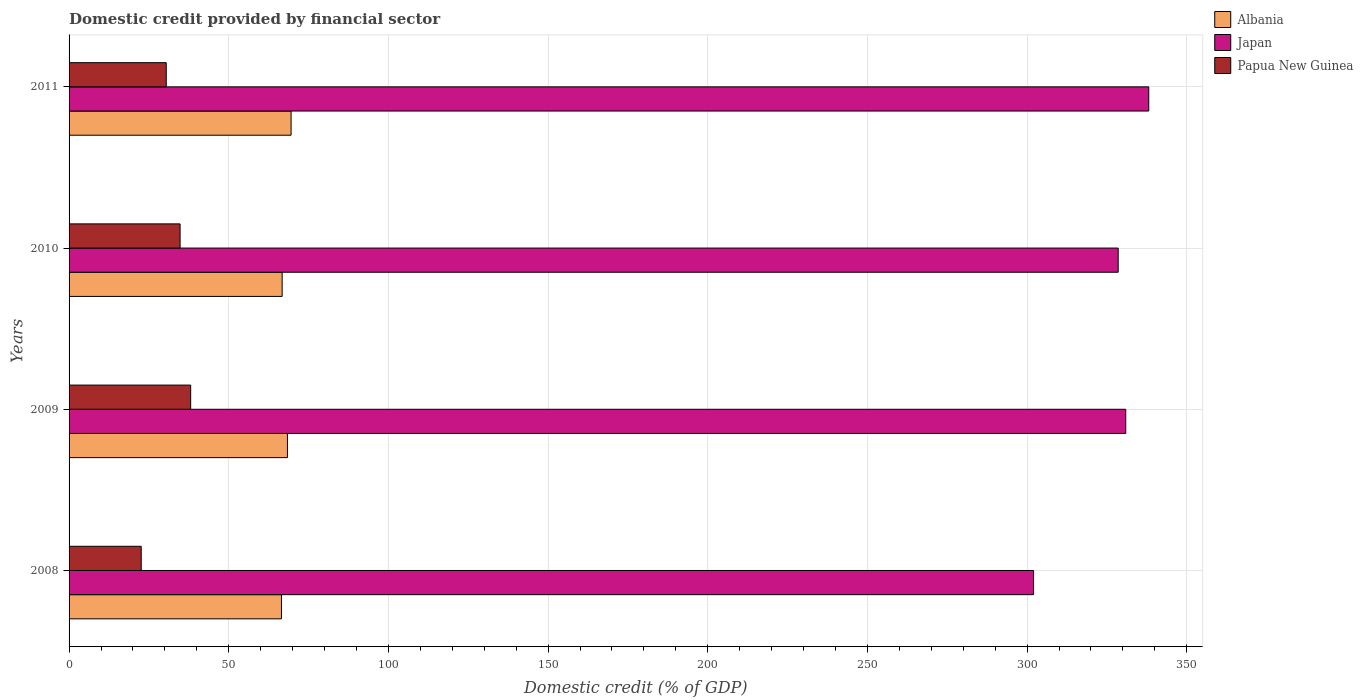How many different coloured bars are there?
Offer a very short reply. 3. Are the number of bars on each tick of the Y-axis equal?
Give a very brief answer. Yes. How many bars are there on the 4th tick from the bottom?
Your response must be concise. 3. What is the label of the 4th group of bars from the top?
Provide a short and direct response. 2008. In how many cases, is the number of bars for a given year not equal to the number of legend labels?
Your answer should be very brief. 0. What is the domestic credit in Albania in 2011?
Give a very brief answer. 69.52. Across all years, what is the maximum domestic credit in Papua New Guinea?
Offer a very short reply. 38.08. Across all years, what is the minimum domestic credit in Albania?
Offer a terse response. 66.51. What is the total domestic credit in Papua New Guinea in the graph?
Ensure brevity in your answer.  125.86. What is the difference between the domestic credit in Papua New Guinea in 2010 and that in 2011?
Your answer should be very brief. 4.34. What is the difference between the domestic credit in Albania in 2010 and the domestic credit in Japan in 2008?
Offer a terse response. -235.29. What is the average domestic credit in Papua New Guinea per year?
Offer a terse response. 31.46. In the year 2008, what is the difference between the domestic credit in Papua New Guinea and domestic credit in Japan?
Provide a short and direct response. -279.43. What is the ratio of the domestic credit in Japan in 2009 to that in 2011?
Make the answer very short. 0.98. Is the domestic credit in Japan in 2009 less than that in 2011?
Make the answer very short. Yes. What is the difference between the highest and the second highest domestic credit in Japan?
Ensure brevity in your answer.  7.2. What is the difference between the highest and the lowest domestic credit in Papua New Guinea?
Offer a terse response. 15.49. What does the 1st bar from the top in 2009 represents?
Offer a very short reply. Papua New Guinea. What does the 2nd bar from the bottom in 2010 represents?
Keep it short and to the point. Japan. Are all the bars in the graph horizontal?
Keep it short and to the point. Yes. How many years are there in the graph?
Make the answer very short. 4. What is the title of the graph?
Your response must be concise. Domestic credit provided by financial sector. What is the label or title of the X-axis?
Your response must be concise. Domestic credit (% of GDP). What is the label or title of the Y-axis?
Keep it short and to the point. Years. What is the Domestic credit (% of GDP) in Albania in 2008?
Offer a terse response. 66.51. What is the Domestic credit (% of GDP) of Japan in 2008?
Provide a succinct answer. 302.02. What is the Domestic credit (% of GDP) of Papua New Guinea in 2008?
Provide a short and direct response. 22.59. What is the Domestic credit (% of GDP) in Albania in 2009?
Offer a terse response. 68.38. What is the Domestic credit (% of GDP) in Japan in 2009?
Offer a terse response. 330.89. What is the Domestic credit (% of GDP) in Papua New Guinea in 2009?
Keep it short and to the point. 38.08. What is the Domestic credit (% of GDP) of Albania in 2010?
Offer a very short reply. 66.72. What is the Domestic credit (% of GDP) of Japan in 2010?
Give a very brief answer. 328.52. What is the Domestic credit (% of GDP) in Papua New Guinea in 2010?
Offer a very short reply. 34.76. What is the Domestic credit (% of GDP) of Albania in 2011?
Provide a succinct answer. 69.52. What is the Domestic credit (% of GDP) in Japan in 2011?
Provide a succinct answer. 338.09. What is the Domestic credit (% of GDP) of Papua New Guinea in 2011?
Keep it short and to the point. 30.43. Across all years, what is the maximum Domestic credit (% of GDP) of Albania?
Your answer should be compact. 69.52. Across all years, what is the maximum Domestic credit (% of GDP) of Japan?
Provide a short and direct response. 338.09. Across all years, what is the maximum Domestic credit (% of GDP) in Papua New Guinea?
Keep it short and to the point. 38.08. Across all years, what is the minimum Domestic credit (% of GDP) of Albania?
Your answer should be compact. 66.51. Across all years, what is the minimum Domestic credit (% of GDP) of Japan?
Provide a short and direct response. 302.02. Across all years, what is the minimum Domestic credit (% of GDP) of Papua New Guinea?
Make the answer very short. 22.59. What is the total Domestic credit (% of GDP) of Albania in the graph?
Your response must be concise. 271.14. What is the total Domestic credit (% of GDP) in Japan in the graph?
Your answer should be very brief. 1299.52. What is the total Domestic credit (% of GDP) in Papua New Guinea in the graph?
Provide a short and direct response. 125.86. What is the difference between the Domestic credit (% of GDP) of Albania in 2008 and that in 2009?
Offer a very short reply. -1.87. What is the difference between the Domestic credit (% of GDP) in Japan in 2008 and that in 2009?
Provide a short and direct response. -28.87. What is the difference between the Domestic credit (% of GDP) of Papua New Guinea in 2008 and that in 2009?
Give a very brief answer. -15.49. What is the difference between the Domestic credit (% of GDP) in Albania in 2008 and that in 2010?
Offer a terse response. -0.21. What is the difference between the Domestic credit (% of GDP) of Japan in 2008 and that in 2010?
Give a very brief answer. -26.5. What is the difference between the Domestic credit (% of GDP) in Papua New Guinea in 2008 and that in 2010?
Your answer should be very brief. -12.17. What is the difference between the Domestic credit (% of GDP) of Albania in 2008 and that in 2011?
Give a very brief answer. -3.01. What is the difference between the Domestic credit (% of GDP) of Japan in 2008 and that in 2011?
Provide a succinct answer. -36.07. What is the difference between the Domestic credit (% of GDP) in Papua New Guinea in 2008 and that in 2011?
Make the answer very short. -7.83. What is the difference between the Domestic credit (% of GDP) in Albania in 2009 and that in 2010?
Your answer should be compact. 1.66. What is the difference between the Domestic credit (% of GDP) of Japan in 2009 and that in 2010?
Give a very brief answer. 2.37. What is the difference between the Domestic credit (% of GDP) in Papua New Guinea in 2009 and that in 2010?
Give a very brief answer. 3.31. What is the difference between the Domestic credit (% of GDP) in Albania in 2009 and that in 2011?
Ensure brevity in your answer.  -1.14. What is the difference between the Domestic credit (% of GDP) in Japan in 2009 and that in 2011?
Provide a short and direct response. -7.2. What is the difference between the Domestic credit (% of GDP) in Papua New Guinea in 2009 and that in 2011?
Give a very brief answer. 7.65. What is the difference between the Domestic credit (% of GDP) in Albania in 2010 and that in 2011?
Keep it short and to the point. -2.79. What is the difference between the Domestic credit (% of GDP) of Japan in 2010 and that in 2011?
Your answer should be compact. -9.57. What is the difference between the Domestic credit (% of GDP) of Papua New Guinea in 2010 and that in 2011?
Your answer should be compact. 4.34. What is the difference between the Domestic credit (% of GDP) in Albania in 2008 and the Domestic credit (% of GDP) in Japan in 2009?
Make the answer very short. -264.38. What is the difference between the Domestic credit (% of GDP) of Albania in 2008 and the Domestic credit (% of GDP) of Papua New Guinea in 2009?
Ensure brevity in your answer.  28.43. What is the difference between the Domestic credit (% of GDP) of Japan in 2008 and the Domestic credit (% of GDP) of Papua New Guinea in 2009?
Your answer should be very brief. 263.94. What is the difference between the Domestic credit (% of GDP) of Albania in 2008 and the Domestic credit (% of GDP) of Japan in 2010?
Your answer should be compact. -262.01. What is the difference between the Domestic credit (% of GDP) of Albania in 2008 and the Domestic credit (% of GDP) of Papua New Guinea in 2010?
Make the answer very short. 31.75. What is the difference between the Domestic credit (% of GDP) in Japan in 2008 and the Domestic credit (% of GDP) in Papua New Guinea in 2010?
Provide a succinct answer. 267.26. What is the difference between the Domestic credit (% of GDP) in Albania in 2008 and the Domestic credit (% of GDP) in Japan in 2011?
Provide a succinct answer. -271.58. What is the difference between the Domestic credit (% of GDP) in Albania in 2008 and the Domestic credit (% of GDP) in Papua New Guinea in 2011?
Your answer should be compact. 36.09. What is the difference between the Domestic credit (% of GDP) of Japan in 2008 and the Domestic credit (% of GDP) of Papua New Guinea in 2011?
Your response must be concise. 271.59. What is the difference between the Domestic credit (% of GDP) of Albania in 2009 and the Domestic credit (% of GDP) of Japan in 2010?
Your answer should be compact. -260.14. What is the difference between the Domestic credit (% of GDP) of Albania in 2009 and the Domestic credit (% of GDP) of Papua New Guinea in 2010?
Your answer should be compact. 33.62. What is the difference between the Domestic credit (% of GDP) of Japan in 2009 and the Domestic credit (% of GDP) of Papua New Guinea in 2010?
Provide a succinct answer. 296.13. What is the difference between the Domestic credit (% of GDP) of Albania in 2009 and the Domestic credit (% of GDP) of Japan in 2011?
Offer a terse response. -269.71. What is the difference between the Domestic credit (% of GDP) in Albania in 2009 and the Domestic credit (% of GDP) in Papua New Guinea in 2011?
Your answer should be compact. 37.96. What is the difference between the Domestic credit (% of GDP) of Japan in 2009 and the Domestic credit (% of GDP) of Papua New Guinea in 2011?
Your response must be concise. 300.46. What is the difference between the Domestic credit (% of GDP) in Albania in 2010 and the Domestic credit (% of GDP) in Japan in 2011?
Offer a terse response. -271.37. What is the difference between the Domestic credit (% of GDP) of Albania in 2010 and the Domestic credit (% of GDP) of Papua New Guinea in 2011?
Provide a succinct answer. 36.3. What is the difference between the Domestic credit (% of GDP) of Japan in 2010 and the Domestic credit (% of GDP) of Papua New Guinea in 2011?
Your answer should be compact. 298.1. What is the average Domestic credit (% of GDP) in Albania per year?
Offer a terse response. 67.78. What is the average Domestic credit (% of GDP) in Japan per year?
Offer a very short reply. 324.88. What is the average Domestic credit (% of GDP) in Papua New Guinea per year?
Make the answer very short. 31.46. In the year 2008, what is the difference between the Domestic credit (% of GDP) in Albania and Domestic credit (% of GDP) in Japan?
Keep it short and to the point. -235.51. In the year 2008, what is the difference between the Domestic credit (% of GDP) of Albania and Domestic credit (% of GDP) of Papua New Guinea?
Give a very brief answer. 43.92. In the year 2008, what is the difference between the Domestic credit (% of GDP) in Japan and Domestic credit (% of GDP) in Papua New Guinea?
Make the answer very short. 279.43. In the year 2009, what is the difference between the Domestic credit (% of GDP) of Albania and Domestic credit (% of GDP) of Japan?
Ensure brevity in your answer.  -262.51. In the year 2009, what is the difference between the Domestic credit (% of GDP) of Albania and Domestic credit (% of GDP) of Papua New Guinea?
Make the answer very short. 30.3. In the year 2009, what is the difference between the Domestic credit (% of GDP) of Japan and Domestic credit (% of GDP) of Papua New Guinea?
Provide a short and direct response. 292.81. In the year 2010, what is the difference between the Domestic credit (% of GDP) in Albania and Domestic credit (% of GDP) in Japan?
Your answer should be compact. -261.8. In the year 2010, what is the difference between the Domestic credit (% of GDP) of Albania and Domestic credit (% of GDP) of Papua New Guinea?
Offer a terse response. 31.96. In the year 2010, what is the difference between the Domestic credit (% of GDP) of Japan and Domestic credit (% of GDP) of Papua New Guinea?
Ensure brevity in your answer.  293.76. In the year 2011, what is the difference between the Domestic credit (% of GDP) in Albania and Domestic credit (% of GDP) in Japan?
Your answer should be compact. -268.57. In the year 2011, what is the difference between the Domestic credit (% of GDP) in Albania and Domestic credit (% of GDP) in Papua New Guinea?
Give a very brief answer. 39.09. In the year 2011, what is the difference between the Domestic credit (% of GDP) of Japan and Domestic credit (% of GDP) of Papua New Guinea?
Your answer should be very brief. 307.66. What is the ratio of the Domestic credit (% of GDP) of Albania in 2008 to that in 2009?
Offer a terse response. 0.97. What is the ratio of the Domestic credit (% of GDP) of Japan in 2008 to that in 2009?
Provide a succinct answer. 0.91. What is the ratio of the Domestic credit (% of GDP) of Papua New Guinea in 2008 to that in 2009?
Ensure brevity in your answer.  0.59. What is the ratio of the Domestic credit (% of GDP) of Albania in 2008 to that in 2010?
Make the answer very short. 1. What is the ratio of the Domestic credit (% of GDP) in Japan in 2008 to that in 2010?
Your answer should be very brief. 0.92. What is the ratio of the Domestic credit (% of GDP) of Papua New Guinea in 2008 to that in 2010?
Your answer should be very brief. 0.65. What is the ratio of the Domestic credit (% of GDP) in Albania in 2008 to that in 2011?
Your answer should be compact. 0.96. What is the ratio of the Domestic credit (% of GDP) of Japan in 2008 to that in 2011?
Keep it short and to the point. 0.89. What is the ratio of the Domestic credit (% of GDP) in Papua New Guinea in 2008 to that in 2011?
Your response must be concise. 0.74. What is the ratio of the Domestic credit (% of GDP) of Albania in 2009 to that in 2010?
Ensure brevity in your answer.  1.02. What is the ratio of the Domestic credit (% of GDP) in Papua New Guinea in 2009 to that in 2010?
Offer a very short reply. 1.1. What is the ratio of the Domestic credit (% of GDP) of Albania in 2009 to that in 2011?
Your answer should be very brief. 0.98. What is the ratio of the Domestic credit (% of GDP) in Japan in 2009 to that in 2011?
Offer a terse response. 0.98. What is the ratio of the Domestic credit (% of GDP) of Papua New Guinea in 2009 to that in 2011?
Your answer should be compact. 1.25. What is the ratio of the Domestic credit (% of GDP) in Albania in 2010 to that in 2011?
Offer a terse response. 0.96. What is the ratio of the Domestic credit (% of GDP) of Japan in 2010 to that in 2011?
Make the answer very short. 0.97. What is the ratio of the Domestic credit (% of GDP) in Papua New Guinea in 2010 to that in 2011?
Offer a terse response. 1.14. What is the difference between the highest and the second highest Domestic credit (% of GDP) in Albania?
Make the answer very short. 1.14. What is the difference between the highest and the second highest Domestic credit (% of GDP) in Japan?
Keep it short and to the point. 7.2. What is the difference between the highest and the second highest Domestic credit (% of GDP) of Papua New Guinea?
Your answer should be very brief. 3.31. What is the difference between the highest and the lowest Domestic credit (% of GDP) of Albania?
Ensure brevity in your answer.  3.01. What is the difference between the highest and the lowest Domestic credit (% of GDP) in Japan?
Make the answer very short. 36.07. What is the difference between the highest and the lowest Domestic credit (% of GDP) in Papua New Guinea?
Ensure brevity in your answer.  15.49. 